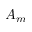Convert formula to latex. <formula><loc_0><loc_0><loc_500><loc_500>A _ { m }</formula> 